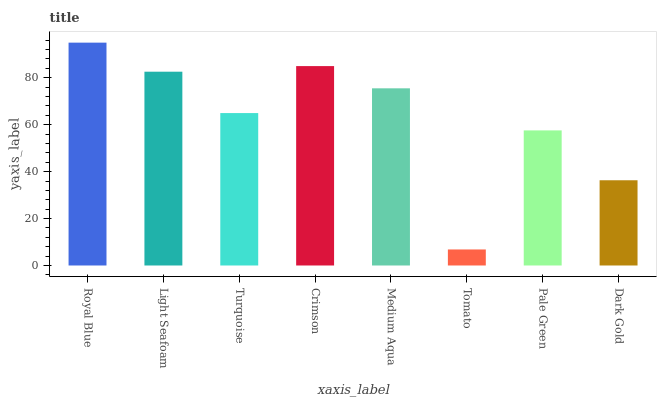Is Tomato the minimum?
Answer yes or no. Yes. Is Royal Blue the maximum?
Answer yes or no. Yes. Is Light Seafoam the minimum?
Answer yes or no. No. Is Light Seafoam the maximum?
Answer yes or no. No. Is Royal Blue greater than Light Seafoam?
Answer yes or no. Yes. Is Light Seafoam less than Royal Blue?
Answer yes or no. Yes. Is Light Seafoam greater than Royal Blue?
Answer yes or no. No. Is Royal Blue less than Light Seafoam?
Answer yes or no. No. Is Medium Aqua the high median?
Answer yes or no. Yes. Is Turquoise the low median?
Answer yes or no. Yes. Is Pale Green the high median?
Answer yes or no. No. Is Crimson the low median?
Answer yes or no. No. 